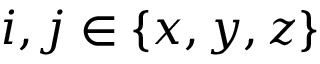<formula> <loc_0><loc_0><loc_500><loc_500>i , j \in \{ x , y , z \}</formula> 